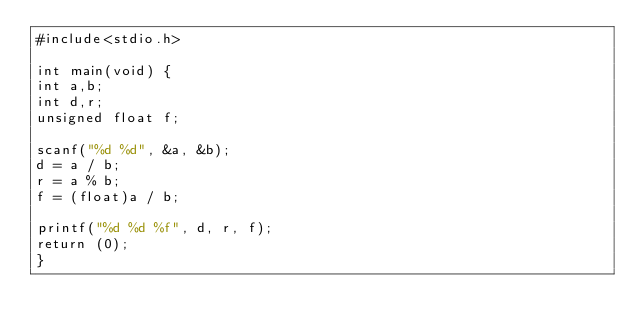Convert code to text. <code><loc_0><loc_0><loc_500><loc_500><_C_>#include<stdio.h>

int main(void) {
int a,b;
int d,r;
unsigned float f;

scanf("%d %d", &a, &b);
d = a / b;
r = a % b;
f = (float)a / b;

printf("%d %d %f", d, r, f);
return (0);
}</code> 